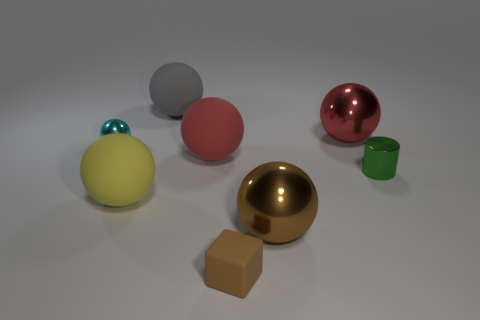Subtract all cyan balls. How many balls are left? 5 Subtract all cyan spheres. How many spheres are left? 5 Subtract all yellow spheres. Subtract all purple cylinders. How many spheres are left? 5 Add 2 tiny metallic objects. How many objects exist? 10 Subtract all cylinders. How many objects are left? 7 Subtract 1 brown cubes. How many objects are left? 7 Subtract all purple balls. Subtract all large red metal things. How many objects are left? 7 Add 8 tiny rubber objects. How many tiny rubber objects are left? 9 Add 7 cyan balls. How many cyan balls exist? 8 